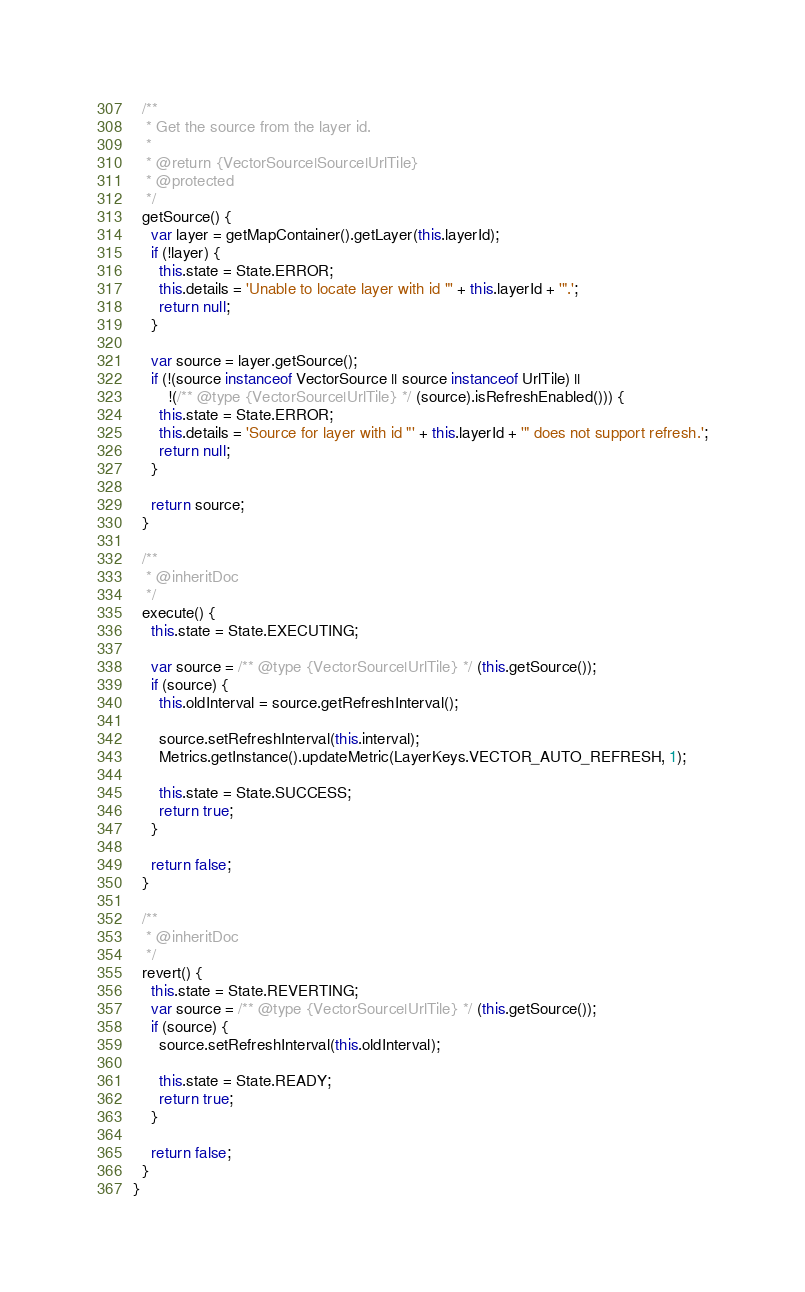<code> <loc_0><loc_0><loc_500><loc_500><_JavaScript_>
  /**
   * Get the source from the layer id.
   *
   * @return {VectorSource|Source|UrlTile}
   * @protected
   */
  getSource() {
    var layer = getMapContainer().getLayer(this.layerId);
    if (!layer) {
      this.state = State.ERROR;
      this.details = 'Unable to locate layer with id "' + this.layerId + '".';
      return null;
    }

    var source = layer.getSource();
    if (!(source instanceof VectorSource || source instanceof UrlTile) ||
        !(/** @type {VectorSource|UrlTile} */ (source).isRefreshEnabled())) {
      this.state = State.ERROR;
      this.details = 'Source for layer with id "' + this.layerId + '" does not support refresh.';
      return null;
    }

    return source;
  }

  /**
   * @inheritDoc
   */
  execute() {
    this.state = State.EXECUTING;

    var source = /** @type {VectorSource|UrlTile} */ (this.getSource());
    if (source) {
      this.oldInterval = source.getRefreshInterval();

      source.setRefreshInterval(this.interval);
      Metrics.getInstance().updateMetric(LayerKeys.VECTOR_AUTO_REFRESH, 1);

      this.state = State.SUCCESS;
      return true;
    }

    return false;
  }

  /**
   * @inheritDoc
   */
  revert() {
    this.state = State.REVERTING;
    var source = /** @type {VectorSource|UrlTile} */ (this.getSource());
    if (source) {
      source.setRefreshInterval(this.oldInterval);

      this.state = State.READY;
      return true;
    }

    return false;
  }
}
</code> 